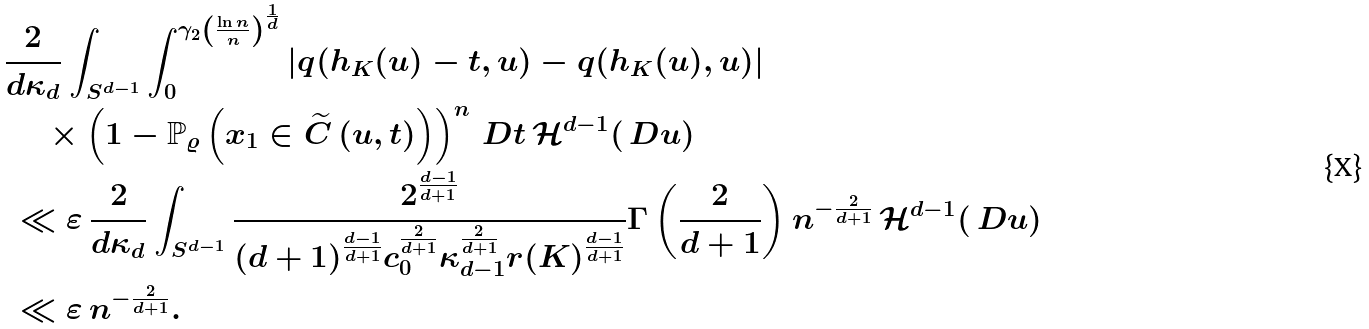Convert formula to latex. <formula><loc_0><loc_0><loc_500><loc_500>& \frac { 2 } { d \kappa _ { d } } \int _ { S ^ { d - 1 } } \int _ { 0 } ^ { \gamma _ { 2 } \left ( \frac { \ln n } { n } \right ) ^ { \frac { 1 } { d } } } \left | q ( h _ { K } ( u ) - t , u ) - q ( h _ { K } ( u ) , u ) \right | \\ & \ \quad \times \left ( 1 - \mathbb { P } _ { \varrho } \left ( x _ { 1 } \in \widetilde { C } \left ( u , t \right ) \right ) \right ) ^ { n } \ D t \, \mathcal { H } ^ { d - 1 } ( \ D u ) \\ & \ \ll \varepsilon \, \frac { 2 } { d \kappa _ { d } } \int _ { S ^ { d - 1 } } \frac { 2 ^ { \frac { d - 1 } { d + 1 } } } { ( d + 1 ) ^ { \frac { d - 1 } { d + 1 } } c _ { 0 } ^ { \frac { 2 } { d + 1 } } \kappa _ { d - 1 } ^ { \frac { 2 } { d + 1 } } r ( K ) ^ { \frac { d - 1 } { d + 1 } } } \Gamma \left ( \frac { 2 } { d + 1 } \right ) n ^ { - \frac { 2 } { d + 1 } } \, \mathcal { H } ^ { d - 1 } ( \ D u ) \\ & \ \ll \varepsilon \, n ^ { - \frac { 2 } { d + 1 } } .</formula> 